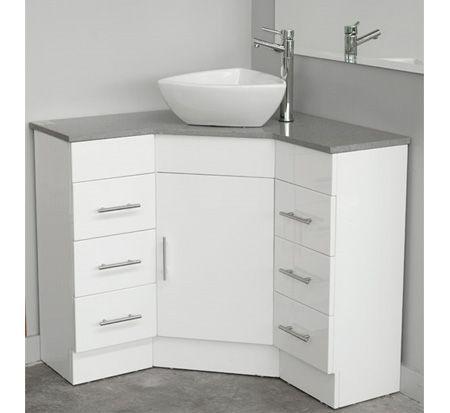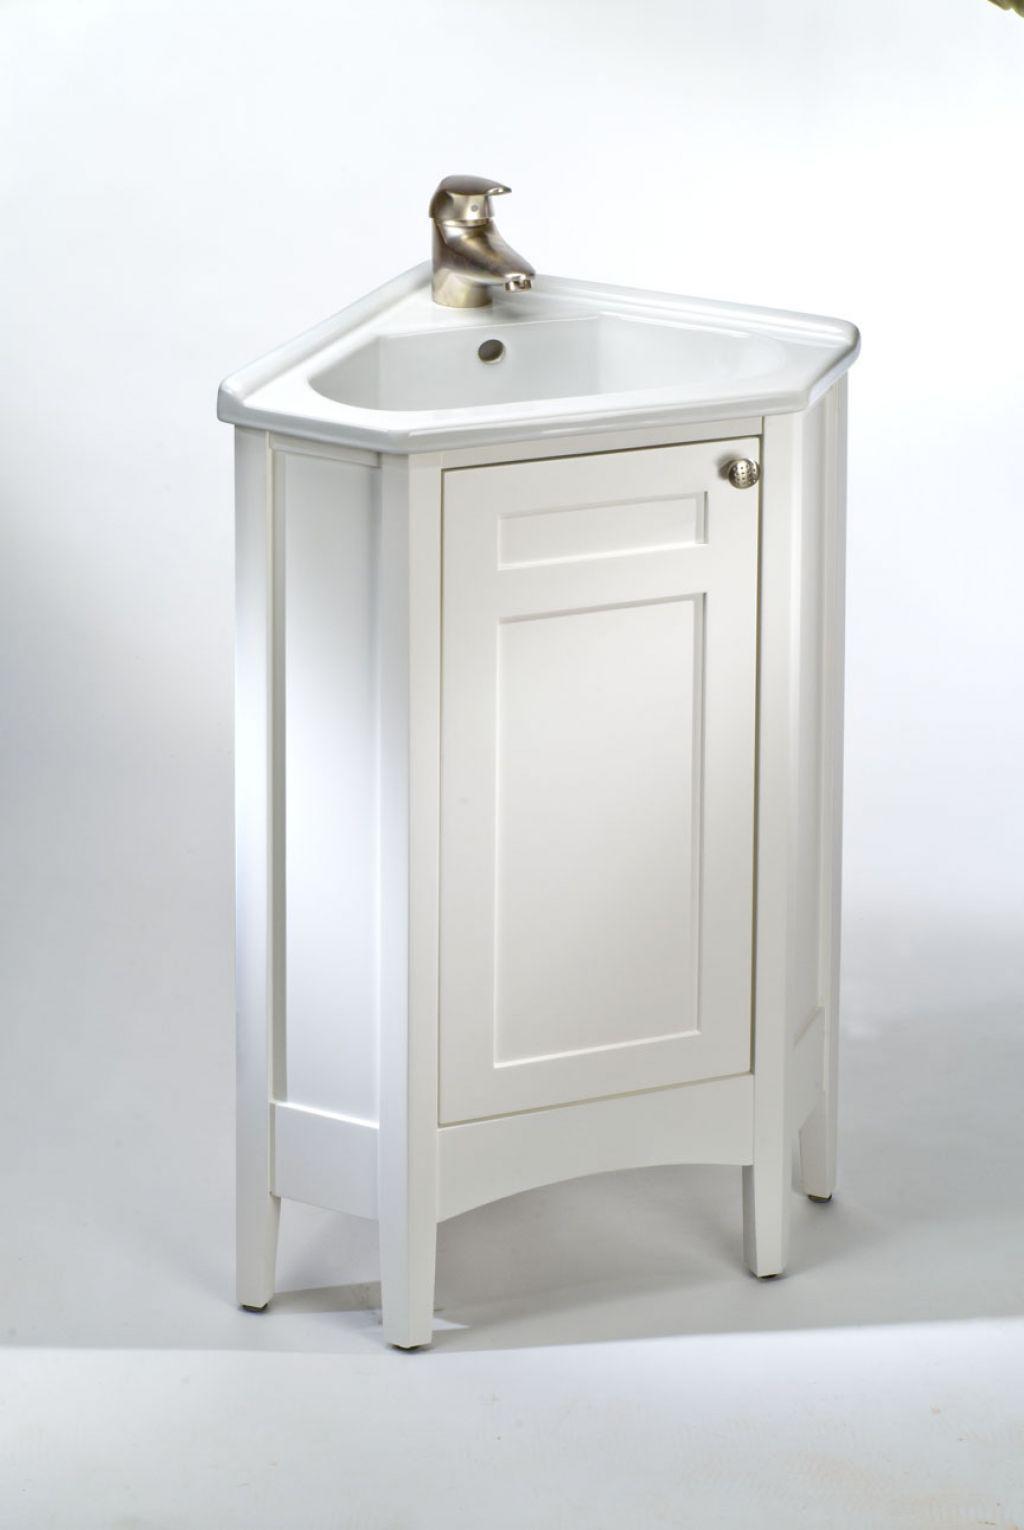The first image is the image on the left, the second image is the image on the right. For the images displayed, is the sentence "Both sink cabinets are corner units." factually correct? Answer yes or no. Yes. The first image is the image on the left, the second image is the image on the right. Analyze the images presented: Is the assertion "One image shows a corner vanity with a white cabinet and an inset sink instead of a vessel sink." valid? Answer yes or no. Yes. 